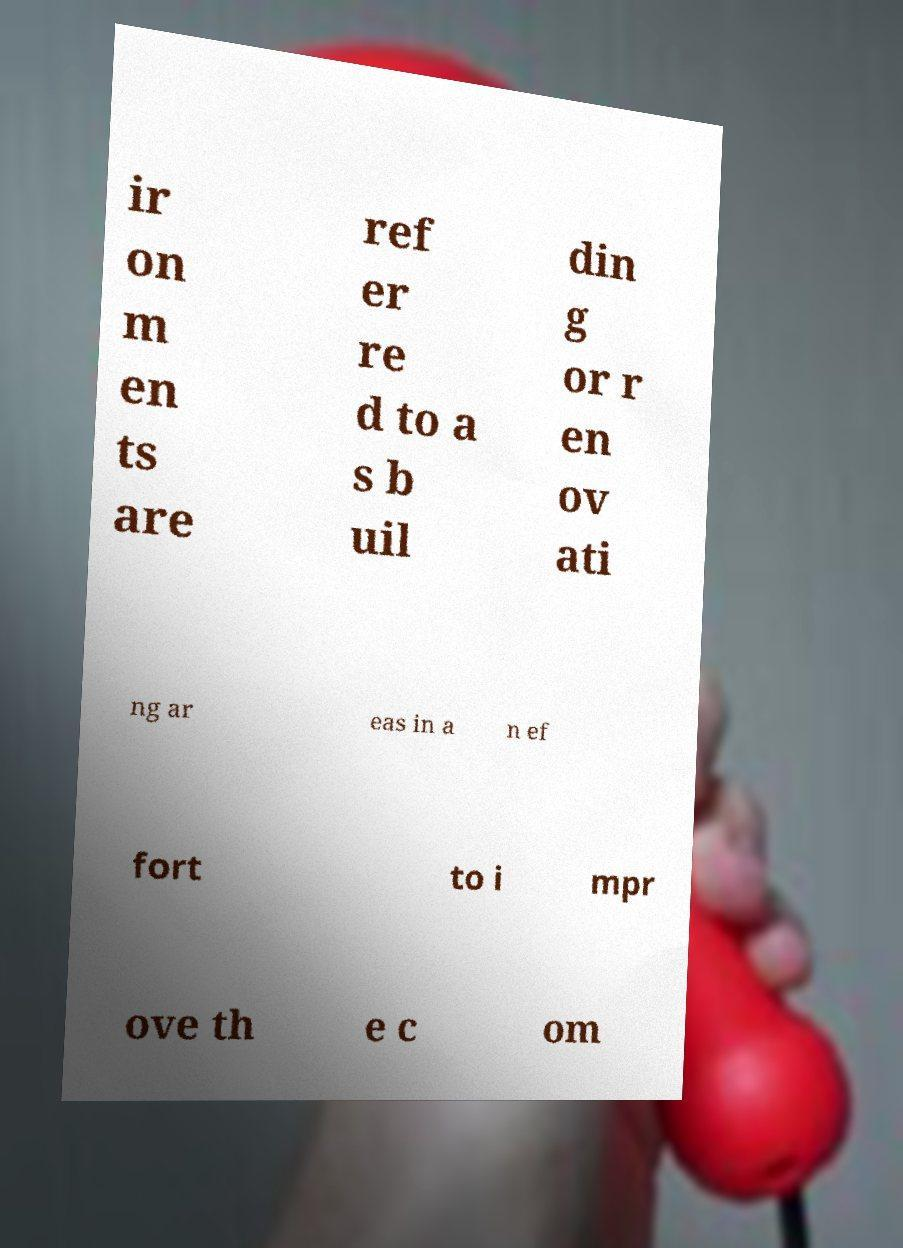Could you assist in decoding the text presented in this image and type it out clearly? ir on m en ts are ref er re d to a s b uil din g or r en ov ati ng ar eas in a n ef fort to i mpr ove th e c om 